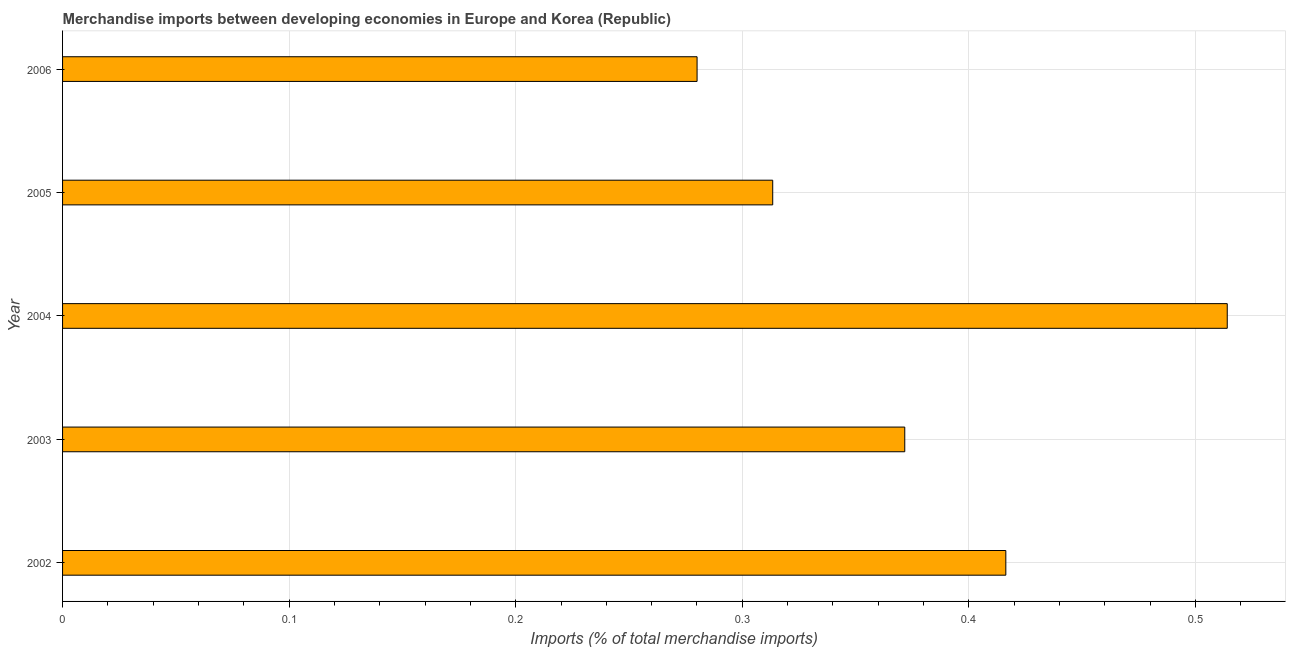Does the graph contain any zero values?
Keep it short and to the point. No. What is the title of the graph?
Make the answer very short. Merchandise imports between developing economies in Europe and Korea (Republic). What is the label or title of the X-axis?
Offer a terse response. Imports (% of total merchandise imports). What is the merchandise imports in 2003?
Offer a very short reply. 0.37. Across all years, what is the maximum merchandise imports?
Your response must be concise. 0.51. Across all years, what is the minimum merchandise imports?
Make the answer very short. 0.28. In which year was the merchandise imports maximum?
Make the answer very short. 2004. What is the sum of the merchandise imports?
Ensure brevity in your answer.  1.9. What is the difference between the merchandise imports in 2002 and 2006?
Provide a succinct answer. 0.14. What is the average merchandise imports per year?
Offer a terse response. 0.38. What is the median merchandise imports?
Offer a terse response. 0.37. Do a majority of the years between 2002 and 2003 (inclusive) have merchandise imports greater than 0.08 %?
Provide a short and direct response. Yes. What is the ratio of the merchandise imports in 2002 to that in 2006?
Make the answer very short. 1.49. Is the merchandise imports in 2004 less than that in 2006?
Ensure brevity in your answer.  No. Is the difference between the merchandise imports in 2003 and 2005 greater than the difference between any two years?
Provide a short and direct response. No. What is the difference between the highest and the second highest merchandise imports?
Give a very brief answer. 0.1. What is the difference between the highest and the lowest merchandise imports?
Offer a very short reply. 0.23. Are all the bars in the graph horizontal?
Your response must be concise. Yes. How many years are there in the graph?
Give a very brief answer. 5. What is the Imports (% of total merchandise imports) of 2002?
Keep it short and to the point. 0.42. What is the Imports (% of total merchandise imports) of 2003?
Provide a short and direct response. 0.37. What is the Imports (% of total merchandise imports) of 2004?
Your answer should be very brief. 0.51. What is the Imports (% of total merchandise imports) of 2005?
Provide a short and direct response. 0.31. What is the Imports (% of total merchandise imports) in 2006?
Make the answer very short. 0.28. What is the difference between the Imports (% of total merchandise imports) in 2002 and 2003?
Offer a very short reply. 0.04. What is the difference between the Imports (% of total merchandise imports) in 2002 and 2004?
Offer a terse response. -0.1. What is the difference between the Imports (% of total merchandise imports) in 2002 and 2005?
Your answer should be compact. 0.1. What is the difference between the Imports (% of total merchandise imports) in 2002 and 2006?
Provide a succinct answer. 0.14. What is the difference between the Imports (% of total merchandise imports) in 2003 and 2004?
Offer a terse response. -0.14. What is the difference between the Imports (% of total merchandise imports) in 2003 and 2005?
Offer a very short reply. 0.06. What is the difference between the Imports (% of total merchandise imports) in 2003 and 2006?
Your response must be concise. 0.09. What is the difference between the Imports (% of total merchandise imports) in 2004 and 2005?
Your answer should be compact. 0.2. What is the difference between the Imports (% of total merchandise imports) in 2004 and 2006?
Your response must be concise. 0.23. What is the difference between the Imports (% of total merchandise imports) in 2005 and 2006?
Keep it short and to the point. 0.03. What is the ratio of the Imports (% of total merchandise imports) in 2002 to that in 2003?
Provide a succinct answer. 1.12. What is the ratio of the Imports (% of total merchandise imports) in 2002 to that in 2004?
Provide a succinct answer. 0.81. What is the ratio of the Imports (% of total merchandise imports) in 2002 to that in 2005?
Your answer should be compact. 1.33. What is the ratio of the Imports (% of total merchandise imports) in 2002 to that in 2006?
Your response must be concise. 1.49. What is the ratio of the Imports (% of total merchandise imports) in 2003 to that in 2004?
Provide a short and direct response. 0.72. What is the ratio of the Imports (% of total merchandise imports) in 2003 to that in 2005?
Keep it short and to the point. 1.19. What is the ratio of the Imports (% of total merchandise imports) in 2003 to that in 2006?
Make the answer very short. 1.33. What is the ratio of the Imports (% of total merchandise imports) in 2004 to that in 2005?
Provide a short and direct response. 1.64. What is the ratio of the Imports (% of total merchandise imports) in 2004 to that in 2006?
Provide a succinct answer. 1.84. What is the ratio of the Imports (% of total merchandise imports) in 2005 to that in 2006?
Make the answer very short. 1.12. 